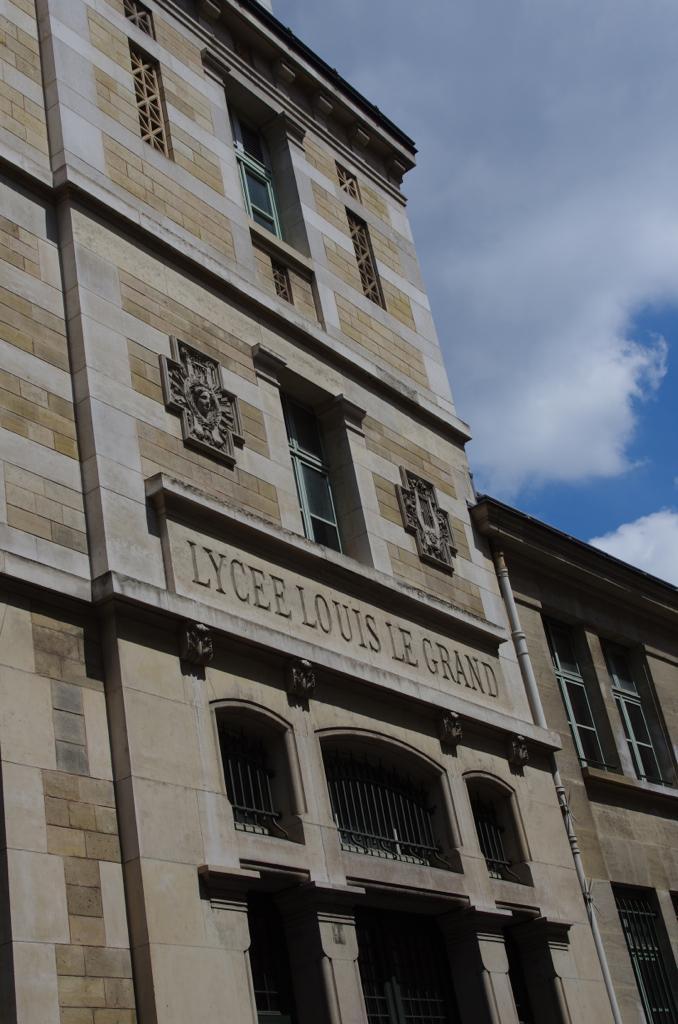Please provide a concise description of this image. In this image there is a building. In the background there is sky. 